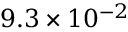Convert formula to latex. <formula><loc_0><loc_0><loc_500><loc_500>9 . 3 \times 1 0 ^ { - 2 }</formula> 